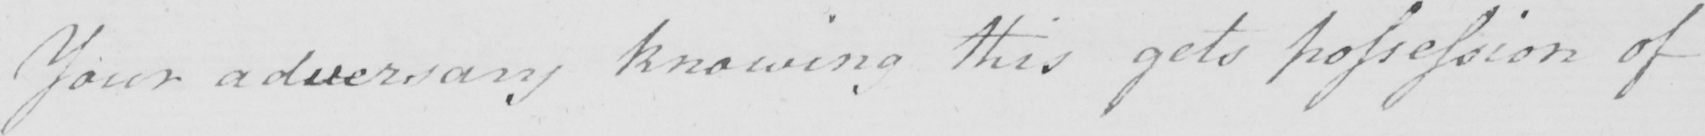What text is written in this handwritten line? Your adversary knowing this gets possession of 